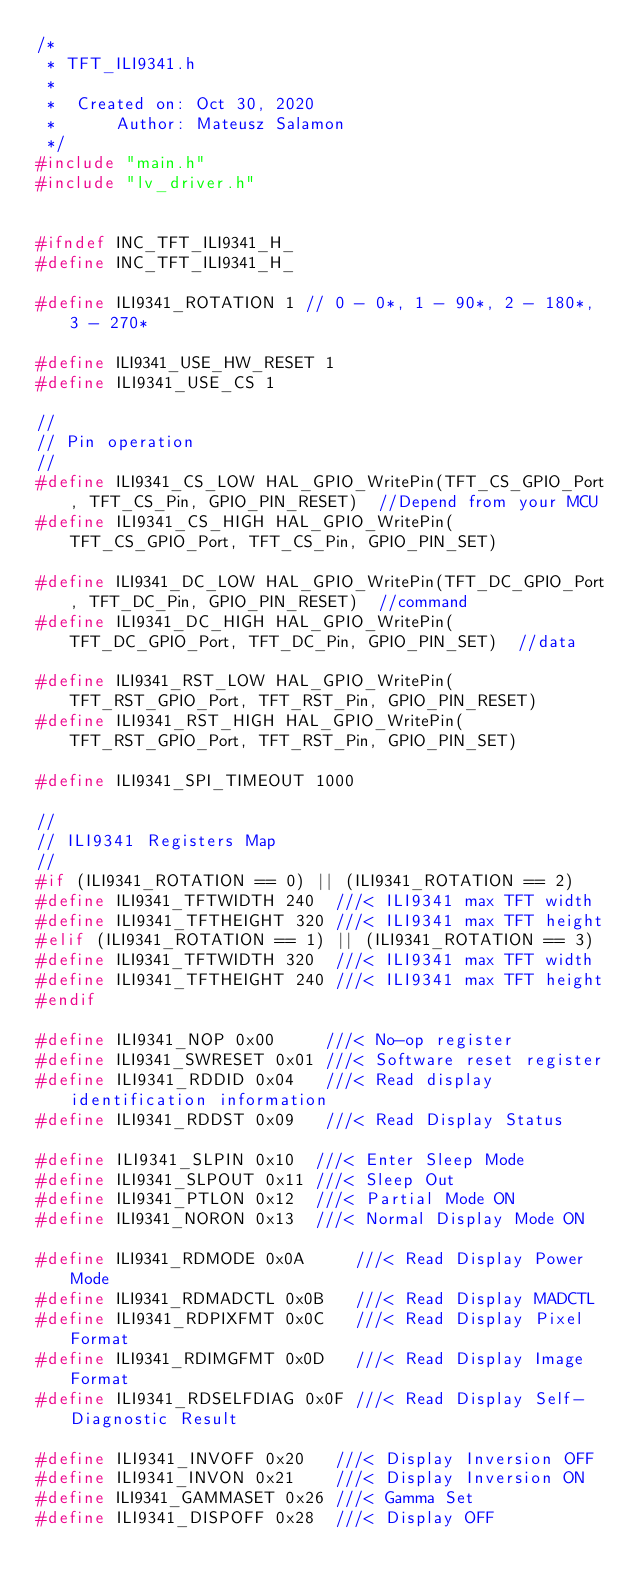<code> <loc_0><loc_0><loc_500><loc_500><_C_>/*
 * TFT_ILI9341.h
 *
 *  Created on: Oct 30, 2020
 *      Author: Mateusz Salamon
 */
#include "main.h"
#include "lv_driver.h"


#ifndef INC_TFT_ILI9341_H_
#define INC_TFT_ILI9341_H_

#define ILI9341_ROTATION 1 // 0 - 0*, 1 - 90*, 2 - 180*, 3 - 270*

#define ILI9341_USE_HW_RESET 1
#define ILI9341_USE_CS 1

//
// Pin operation
//
#define ILI9341_CS_LOW HAL_GPIO_WritePin(TFT_CS_GPIO_Port, TFT_CS_Pin, GPIO_PIN_RESET)  //Depend from your MCU
#define ILI9341_CS_HIGH HAL_GPIO_WritePin(TFT_CS_GPIO_Port, TFT_CS_Pin, GPIO_PIN_SET)

#define ILI9341_DC_LOW HAL_GPIO_WritePin(TFT_DC_GPIO_Port, TFT_DC_Pin, GPIO_PIN_RESET)  //command
#define ILI9341_DC_HIGH HAL_GPIO_WritePin(TFT_DC_GPIO_Port, TFT_DC_Pin, GPIO_PIN_SET)  //data

#define ILI9341_RST_LOW HAL_GPIO_WritePin(TFT_RST_GPIO_Port, TFT_RST_Pin, GPIO_PIN_RESET)
#define ILI9341_RST_HIGH HAL_GPIO_WritePin(TFT_RST_GPIO_Port, TFT_RST_Pin, GPIO_PIN_SET)

#define ILI9341_SPI_TIMEOUT 1000

//
// ILI9341 Registers Map
//
#if (ILI9341_ROTATION == 0) || (ILI9341_ROTATION == 2)
#define ILI9341_TFTWIDTH 240  ///< ILI9341 max TFT width
#define ILI9341_TFTHEIGHT 320 ///< ILI9341 max TFT height
#elif (ILI9341_ROTATION == 1) || (ILI9341_ROTATION == 3)
#define ILI9341_TFTWIDTH 320  ///< ILI9341 max TFT width
#define ILI9341_TFTHEIGHT 240 ///< ILI9341 max TFT height
#endif

#define ILI9341_NOP 0x00     ///< No-op register
#define ILI9341_SWRESET 0x01 ///< Software reset register
#define ILI9341_RDDID 0x04   ///< Read display identification information
#define ILI9341_RDDST 0x09   ///< Read Display Status

#define ILI9341_SLPIN 0x10  ///< Enter Sleep Mode
#define ILI9341_SLPOUT 0x11 ///< Sleep Out
#define ILI9341_PTLON 0x12  ///< Partial Mode ON
#define ILI9341_NORON 0x13  ///< Normal Display Mode ON

#define ILI9341_RDMODE 0x0A     ///< Read Display Power Mode
#define ILI9341_RDMADCTL 0x0B   ///< Read Display MADCTL
#define ILI9341_RDPIXFMT 0x0C   ///< Read Display Pixel Format
#define ILI9341_RDIMGFMT 0x0D   ///< Read Display Image Format
#define ILI9341_RDSELFDIAG 0x0F ///< Read Display Self-Diagnostic Result

#define ILI9341_INVOFF 0x20   ///< Display Inversion OFF
#define ILI9341_INVON 0x21    ///< Display Inversion ON
#define ILI9341_GAMMASET 0x26 ///< Gamma Set
#define ILI9341_DISPOFF 0x28  ///< Display OFF</code> 